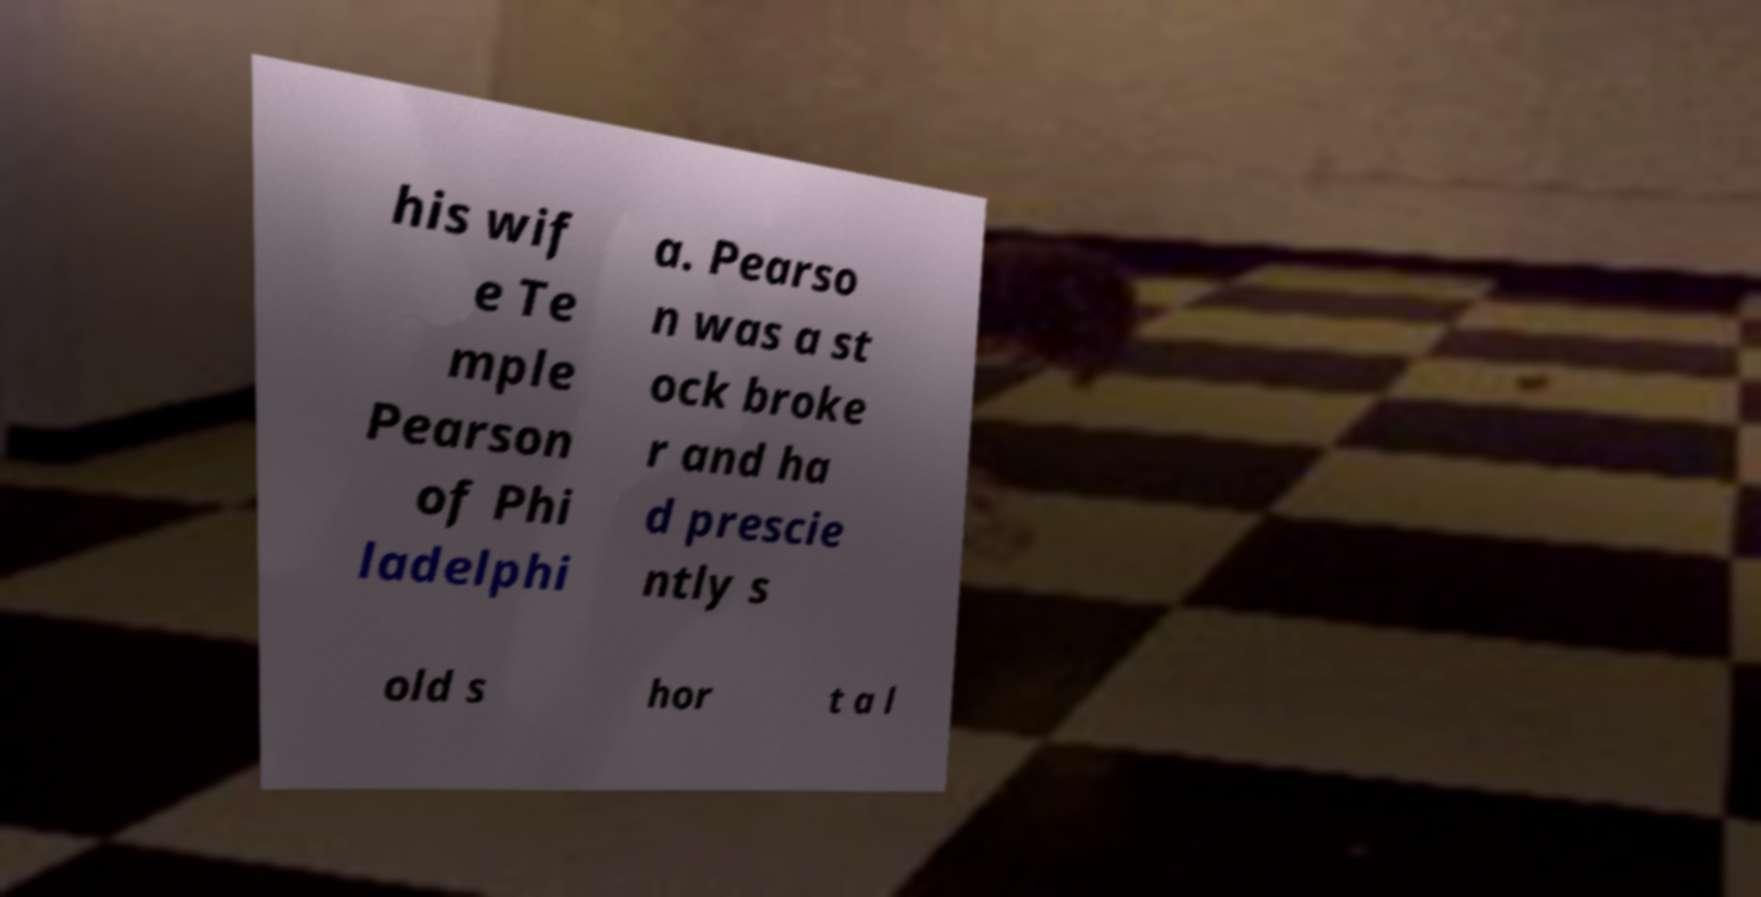What messages or text are displayed in this image? I need them in a readable, typed format. his wif e Te mple Pearson of Phi ladelphi a. Pearso n was a st ock broke r and ha d prescie ntly s old s hor t a l 